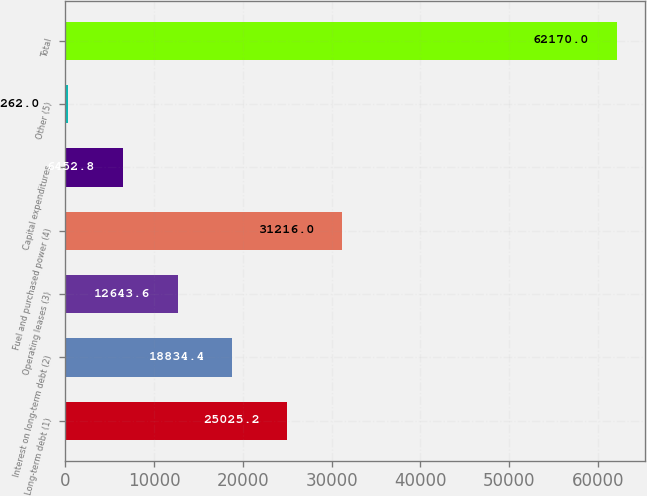Convert chart to OTSL. <chart><loc_0><loc_0><loc_500><loc_500><bar_chart><fcel>Long-term debt (1)<fcel>Interest on long-term debt (2)<fcel>Operating leases (3)<fcel>Fuel and purchased power (4)<fcel>Capital expenditures<fcel>Other (5)<fcel>Total<nl><fcel>25025.2<fcel>18834.4<fcel>12643.6<fcel>31216<fcel>6452.8<fcel>262<fcel>62170<nl></chart> 